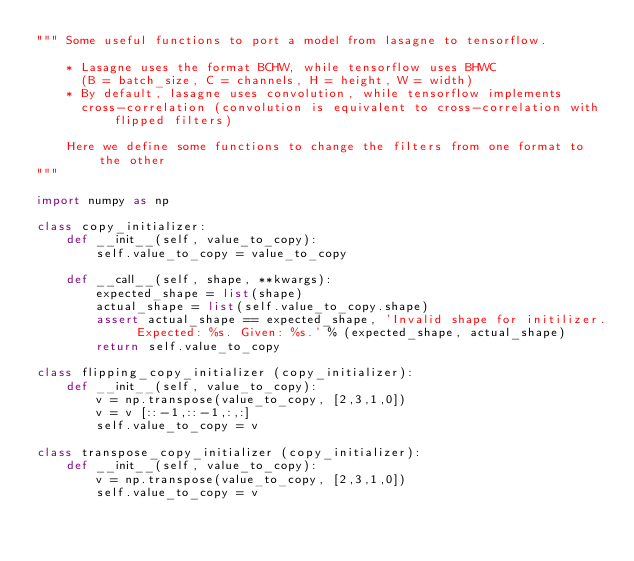<code> <loc_0><loc_0><loc_500><loc_500><_Python_>""" Some useful functions to port a model from lasagne to tensorflow.

    * Lasagne uses the format BCHW, while tensorflow uses BHWC 
      (B = batch_size, C = channels, H = height, W = width)
    * By default, lasagne uses convolution, while tensorflow implements
      cross-correlation (convolution is equivalent to cross-correlation with flipped filters)

    Here we define some functions to change the filters from one format to the other
"""

import numpy as np

class copy_initializer:
    def __init__(self, value_to_copy):
        self.value_to_copy = value_to_copy

    def __call__(self, shape, **kwargs):
        expected_shape = list(shape)
        actual_shape = list(self.value_to_copy.shape)
        assert actual_shape == expected_shape, 'Invalid shape for initilizer. Expected: %s. Given: %s.' % (expected_shape, actual_shape)
        return self.value_to_copy

class flipping_copy_initializer (copy_initializer):
    def __init__(self, value_to_copy):
        v = np.transpose(value_to_copy, [2,3,1,0])
        v = v [::-1,::-1,:,:]
        self.value_to_copy = v

class transpose_copy_initializer (copy_initializer):
    def __init__(self, value_to_copy):
        v = np.transpose(value_to_copy, [2,3,1,0])
        self.value_to_copy = v
</code> 